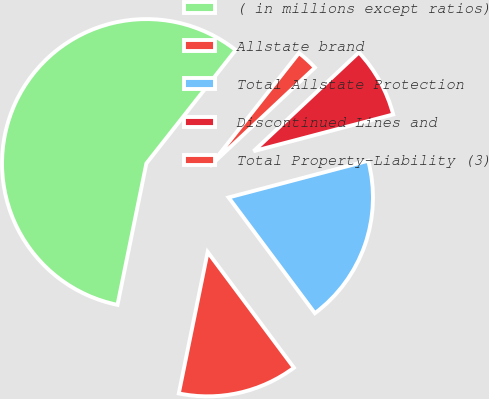Convert chart. <chart><loc_0><loc_0><loc_500><loc_500><pie_chart><fcel>( in millions except ratios)<fcel>Allstate brand<fcel>Total Allstate Protection<fcel>Discontinued Lines and<fcel>Total Property-Liability (3)<nl><fcel>57.41%<fcel>13.4%<fcel>18.9%<fcel>7.9%<fcel>2.39%<nl></chart> 